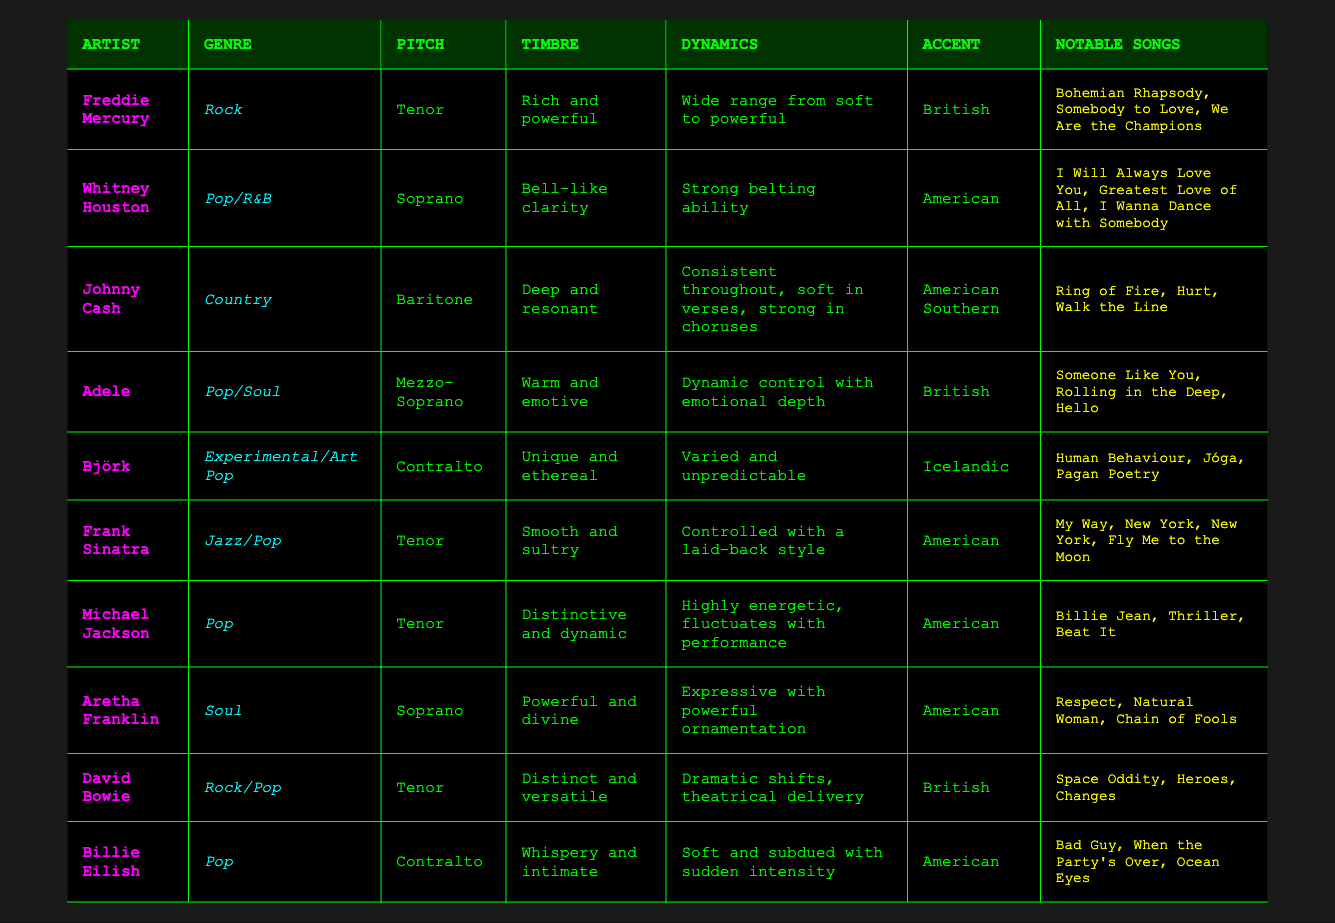What is the voice pitch of Aretha Franklin? Looking at the table, under the row for Aretha Franklin, the "Pitch" column shows "Soprano."
Answer: Soprano Which artist’s voice has a "smooth and sultry" timbre? Referring to the table, Frank Sinatra is listed with the timbre description "Smooth and sultry."
Answer: Frank Sinatra What notable song did Adele perform? Under the "Notable Songs" column for Adele, the song "Someone Like You" is mentioned as one of her notable songs.
Answer: Someone Like You Is Johnny Cash's accent American Southern? The accent listed for Johnny Cash in the table is "American Southern," confirming that the statement is true.
Answer: Yes Which artist has a "dynamic control with emotional depth"? The table specifies that Adele exhibits "Dynamic control with emotional depth" in her characteristics.
Answer: Adele How many artists have a pitch classified as "Tenor"? In the table, the artists listed with a pitch of "Tenor" are Freddie Mercury, Frank Sinatra, and Michael Jackson. This makes a total of three artists.
Answer: 3 What genre does Björk belong to? In the respective row for Björk, the genre is categorized as "Experimental/Art Pop."
Answer: Experimental/Art Pop Which artist has the widest dynamics, from soft to powerful? The table describes Freddie Mercury as having dynamics that range from soft to powerful.
Answer: Freddie Mercury Are there any artists who are classified as Contralto? Referring to the table, there are two artists classified as "Contralto": Björk and Billie Eilish. This confirms the existence of artists in this category.
Answer: Yes Who are the artists known for their powerful voices based on timbre? Both Aretha Franklin ("Powerful and divine") and Whitney Houston ("Bell-like clarity") are noted for their powerful timbre in the table.
Answer: Aretha Franklin, Whitney Houston Which artist performs "Billie Jean"? According to the notable songs listed for Michael Jackson in the table, he performs "Billie Jean."
Answer: Michael Jackson What is the relationship between vocal pitch and artist genre for Soprano singers in the table? The table contains two Soprano singers: Whitney Houston in Pop/R&B and Aretha Franklin in Soul, implying a relationship where Soprano pitches are found in diverse genres.
Answer: Pop/R&B and Soul 